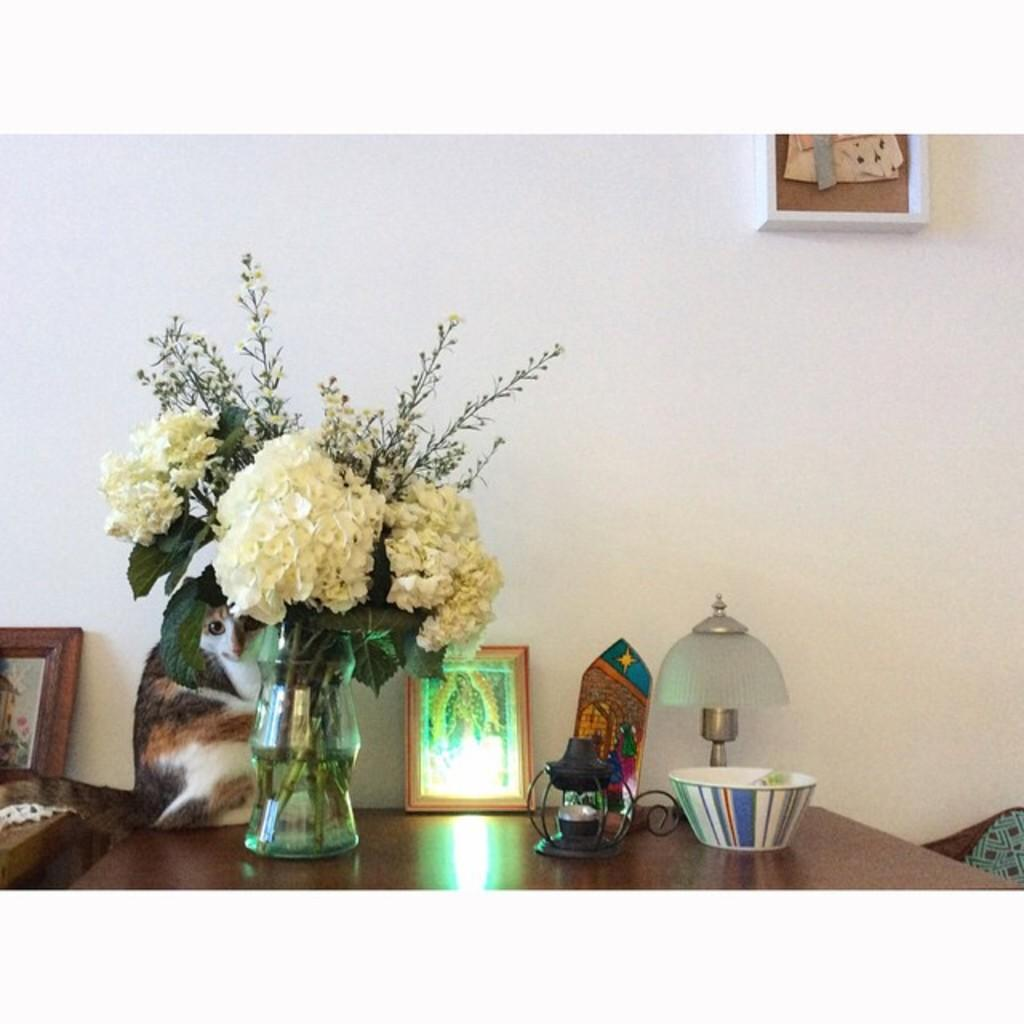What is on the table in the image? There is a flower vase, a cat, and a bowl on the table. Can you describe the cat's position on the table? The cat is on the table. What is the purpose of the bowl on the table? The purpose of the bowl is not specified in the image, but it could be used for holding food or other items. What type of badge is the cat wearing in the image? There is no badge present on the cat in the image. How many wheels can be seen on the table in the image? There are no wheels visible on the table in the image. 